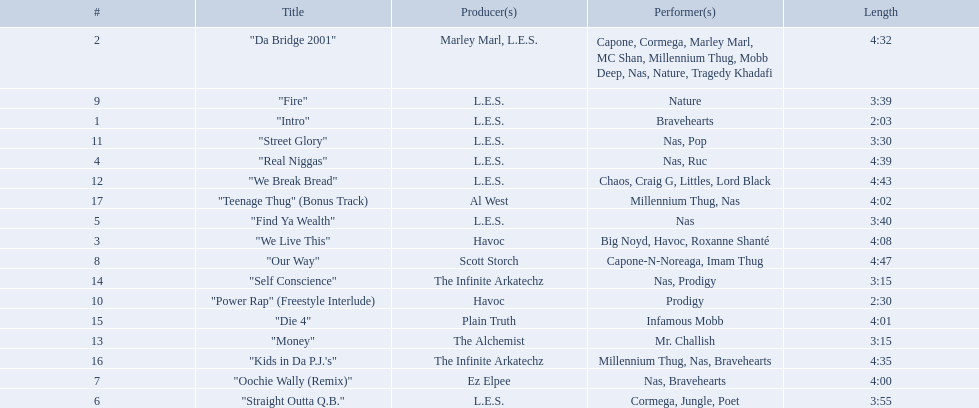How long is each song? 2:03, 4:32, 4:08, 4:39, 3:40, 3:55, 4:00, 4:47, 3:39, 2:30, 3:30, 4:43, 3:15, 3:15, 4:01, 4:35, 4:02. What length is the longest? 4:47. 